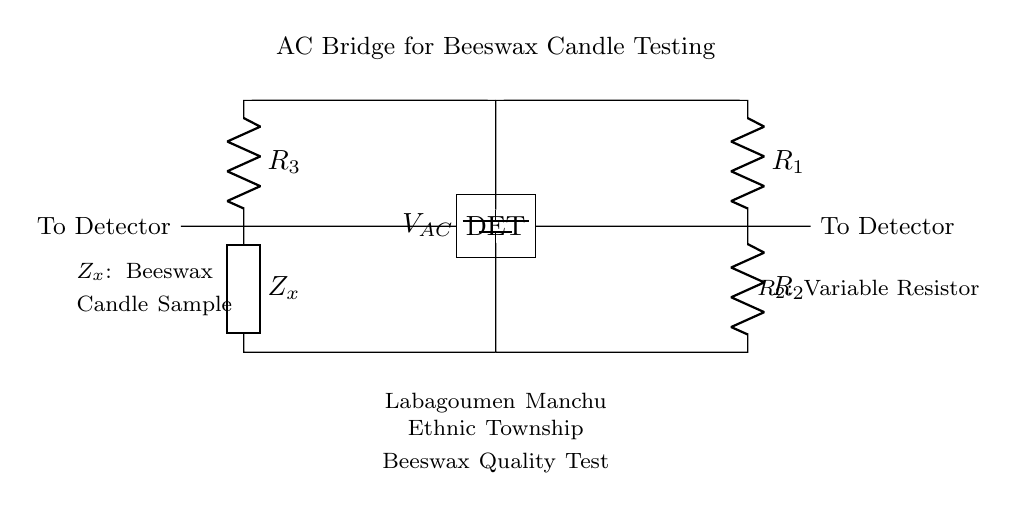What is the voltage source in this circuit? The voltage source is labeled as \( V_{AC} \). It represents the alternating current voltage that powers the AC bridge circuit.
Answer: \( V_{AC} \) What type of component is labeled \( Z_x \)? \( Z_x \) is labeled as a generic component, which signifies that it represents the beeswax candle sample being tested for quality in this context.
Answer: Beeswax candle sample What is the purpose of \( R_2 \) in the circuit? \( R_2 \) is a variable resistor, which allows for adjustments in resistance to balance the bridge and measure the quality of the beeswax candles accurately.
Answer: Variable resistor Which components are connected vertically on the left side of the diagram? The components that are connected vertically on the left side are the resistors \( R_3 \) and \( Z_x \), forming part of the AC bridge circuit.
Answer: \( R_3 \) and \( Z_x \) How many resistors are present in this circuit? There are three resistors indicated in the circuit: \( R_1 \), \( R_2 \), and \( R_3 \), contributing to the balance of the bridge.
Answer: Three resistors What does the label "DET" signify in the diagram? The label "DET" stands for detector, indicating that this part of the circuit is responsible for detecting the output from the bridge after it has been balanced for the beeswax candle's properties.
Answer: Detector Why is this circuit described as an AC bridge? This circuit is classified as an AC bridge because it uses an alternating current voltage source and employs a bridge configuration that allows for the comparison of impedances for quality testing.
Answer: AC bridge 